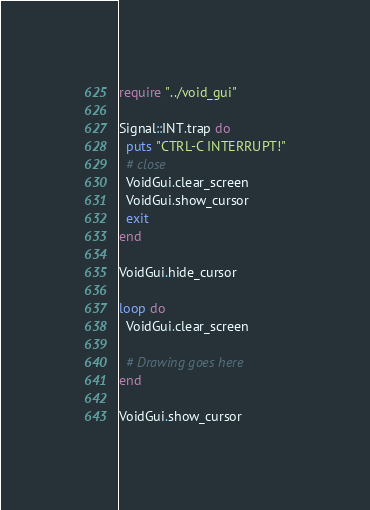Convert code to text. <code><loc_0><loc_0><loc_500><loc_500><_Crystal_>require "../void_gui"

Signal::INT.trap do
  puts "CTRL-C INTERRUPT!"
  # close
  VoidGui.clear_screen
  VoidGui.show_cursor
  exit
end

VoidGui.hide_cursor

loop do
  VoidGui.clear_screen

  # Drawing goes here
end

VoidGui.show_cursor
</code> 